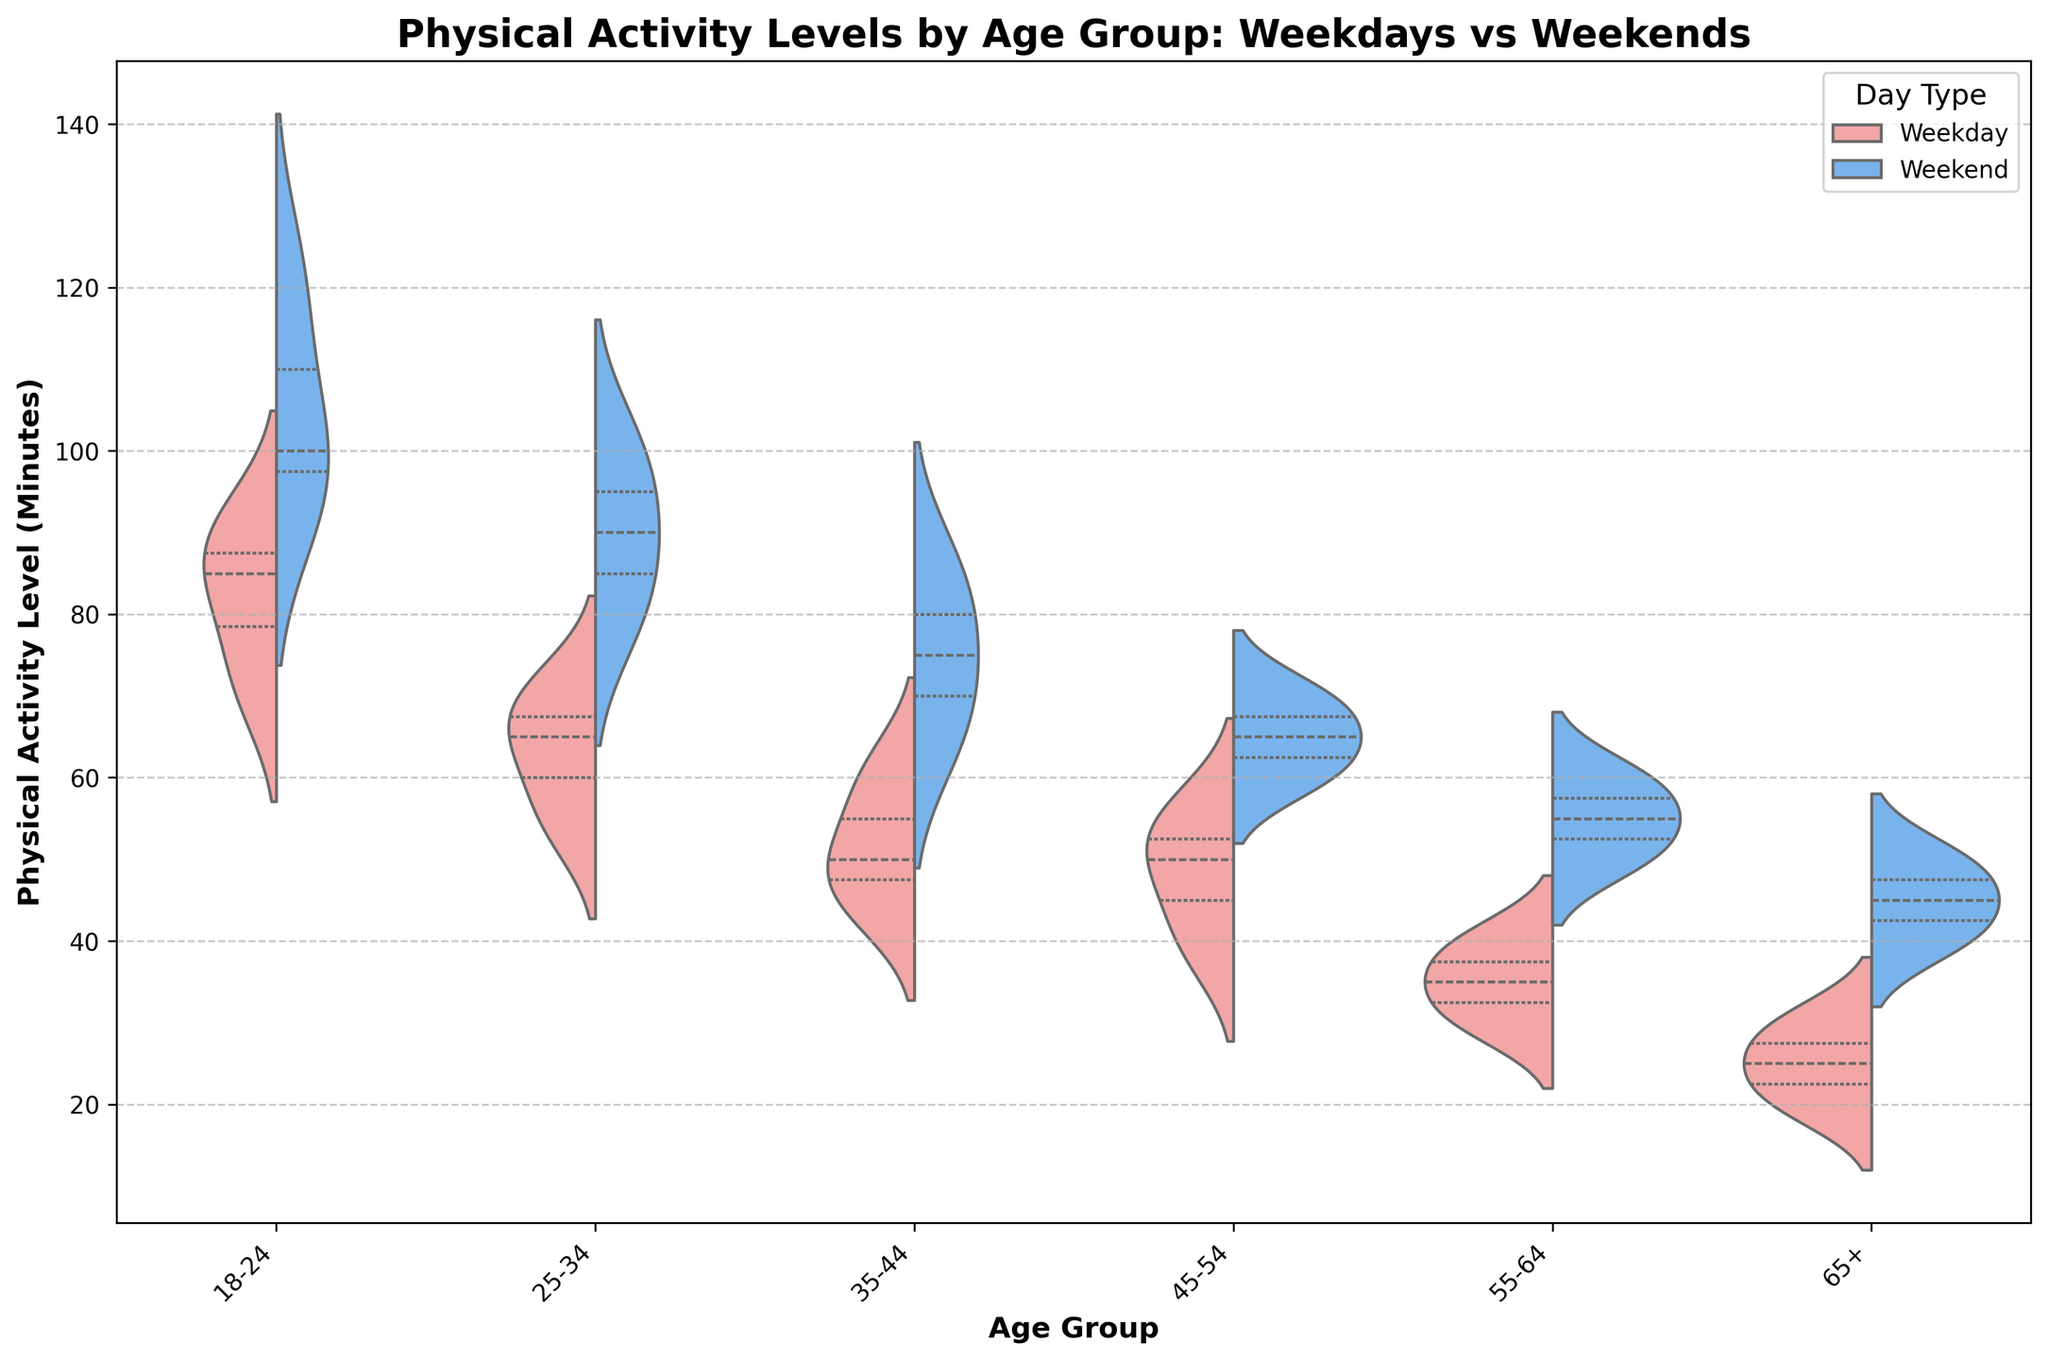What's the title of the figure? The title of the figure is usually located at the top and it describes what the chart represents.
Answer: Physical Activity Levels by Age Group: Weekdays vs Weekends How does the weekday physical activity level vary across age groups? To answer this, look at the portion of the violin plot that corresponds to weekdays; it is colored in red. You can see the general dispersion and central tendency of physical activity levels for each age group.
Answer: Physical activity level generally decreases with age Which age group exhibits the highest variance in physical activity levels during weekends? Variance can be identified by looking at the width of the violin plot. The age group with the widest spread indicates the highest variance. The wider the plot, the higher the variance. For weekends, the 18-24 age group has the widest spread.
Answer: 18-24 On weekdays, which age group has the lowest median physical activity level? The median is indicated by the horizontal line within the violin plot. By comparing the horizontal lines for weekdays across all age groups, you can identify that for the 65+ age group, the median is lowest.
Answer: 65+ Comparing the physical activity levels on weekends, which age group has higher levels: 25-34 or 35-44? By analyzing the blue portion of the violin plot for both 25-34 and 35-44 age groups and comparing the central tendencies (medians), it can be deduced that 25-34 shows higher physical activity levels than 35-44.
Answer: 25-34 Between weekdays and weekends, in which day type do all age groups show consistently greater physical activity levels? To determine this, compare the two halves of each violin plot for all age groups. The weekend portion (blue) is consistently higher than the weekday portion (red).
Answer: Weekends Which age group shows the biggest difference in physical activity levels between weekdays and weekends? You will identify the difference by examining the shift in the central tendency (median) in the two halves of each violin plot for all age groups. The 18-24 age group shows the largest difference, with a significant increase on weekends.
Answer: 18-24 For the 45-54 age group, what are the approximate median physical activity levels for weekdays and weekends? The median is represented by a white dot or line within the violin plot. For the 45-54 age group, the weekday median is roughly around 50 minutes, and the weekend median is around 65 minutes.
Answer: Weekday: 50, Weekend: 65 